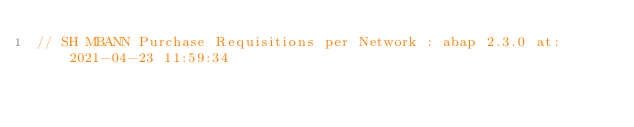Convert code to text. <code><loc_0><loc_0><loc_500><loc_500><_JavaScript_>// SH MBANN Purchase Requisitions per Network : abap 2.3.0 at: 2021-04-23 11:59:34
</code> 